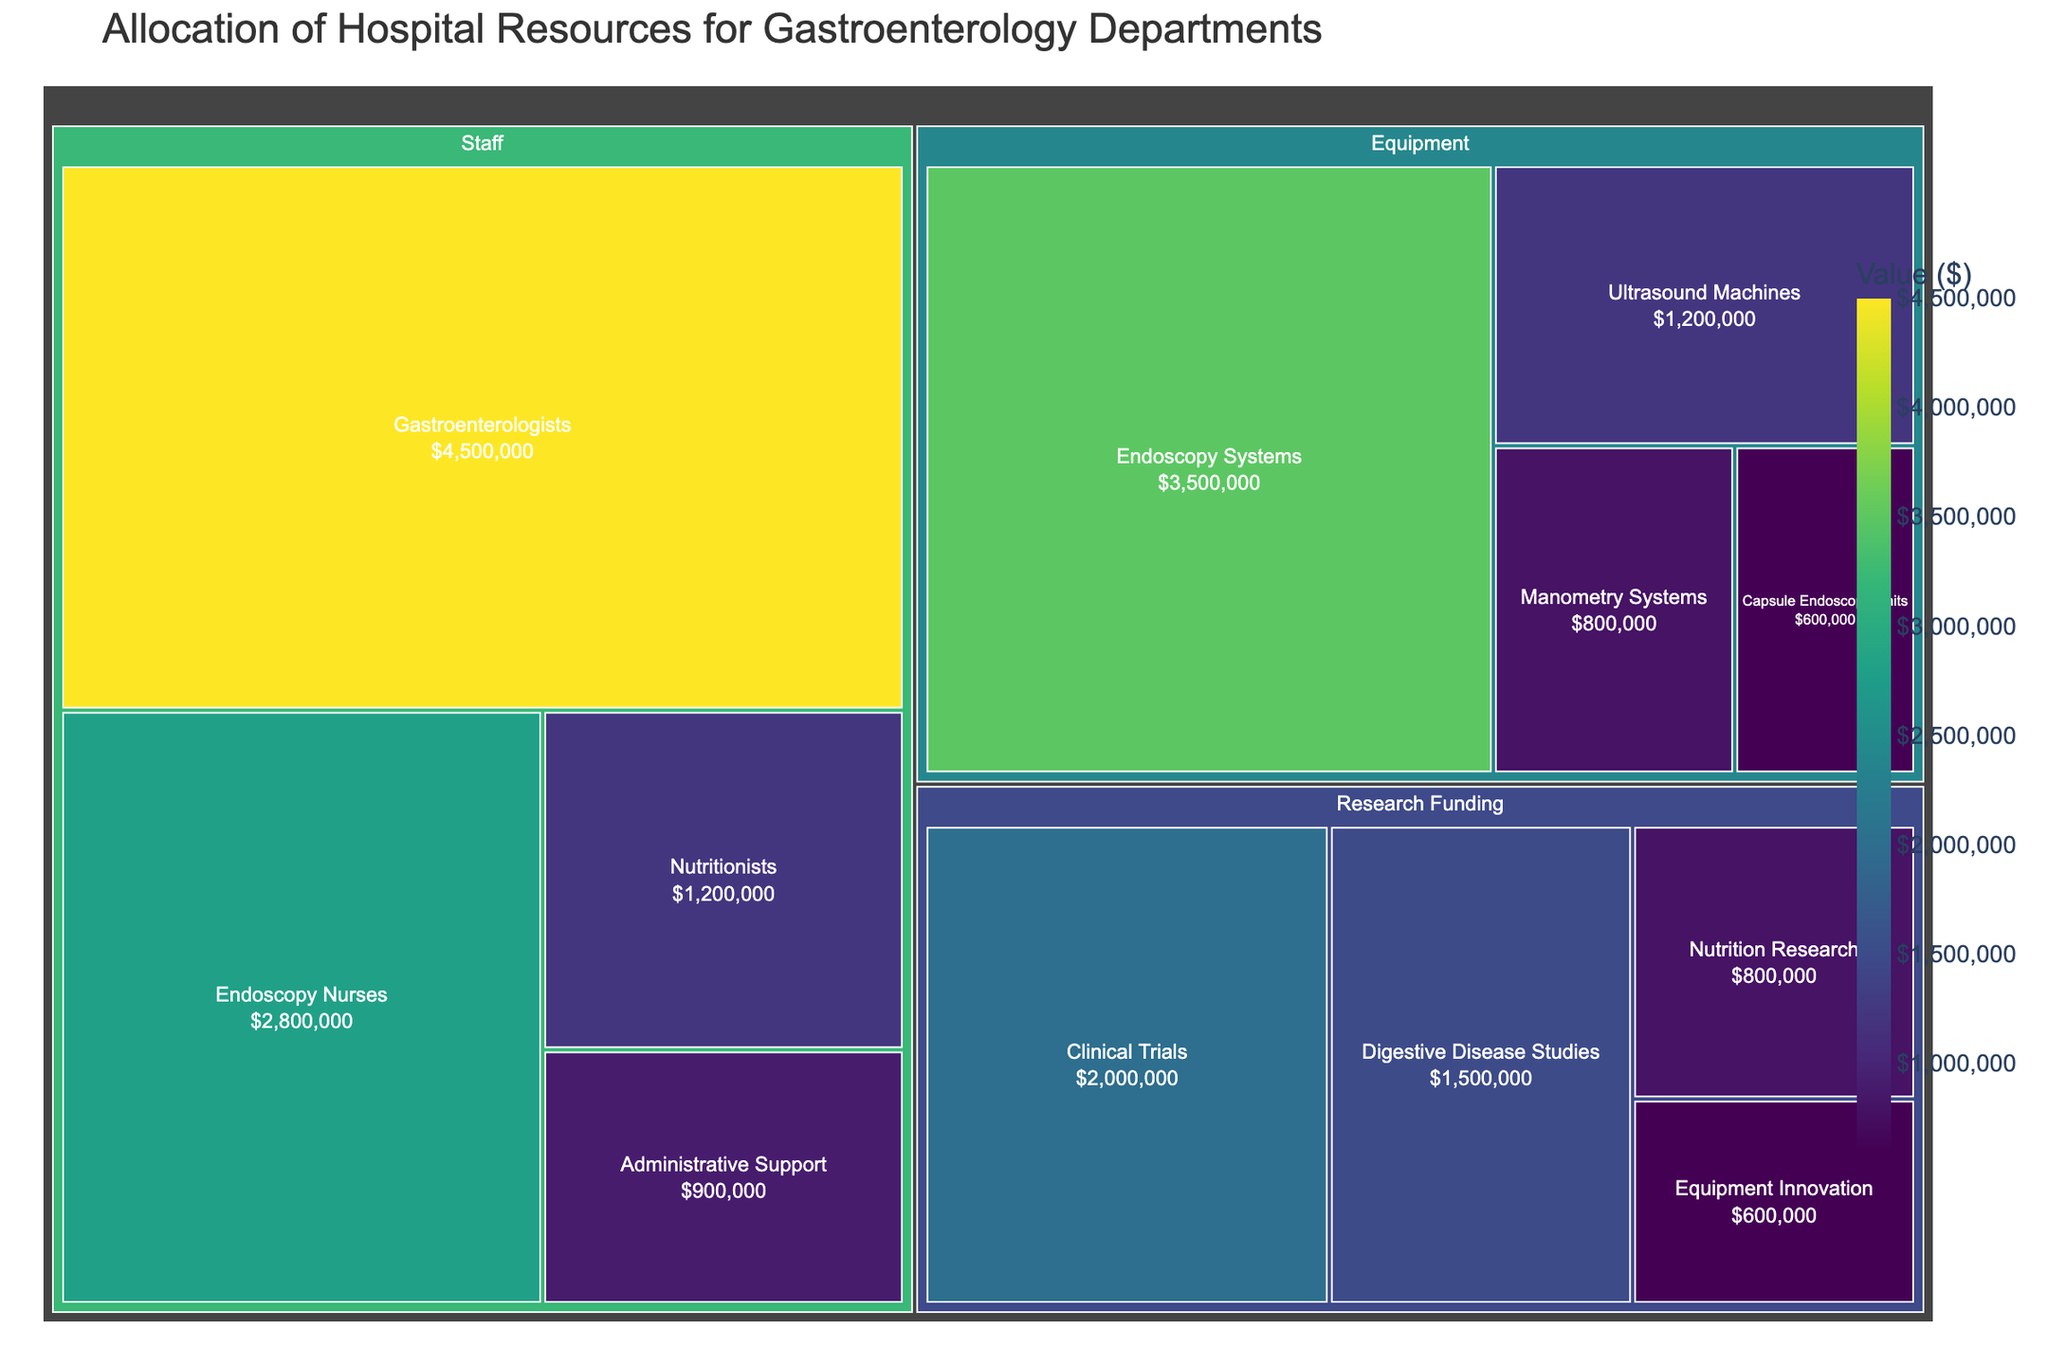What category has the highest overall allocation? By looking at the treemap, the largest portion is dedicated to 'Staff'. Hovering over its subcategories shows significant sums, especially for 'Gastroenterologists'.
Answer: Staff Which subcategory within the 'Equipment' category has the highest value? In the 'Equipment' section of the treemap, the 'Endoscopy Systems' subcategory is the largest portion visually and confirmed by the hover text.
Answer: Endoscopy Systems What is the combined value of 'Endoscopy Nurses' and 'Nutritionists' in the staff category? The value for 'Endoscopy Nurses' is $2,800,000 and for 'Nutritionists' is $1,200,000. Their combined total is 2,800,000 + 1,200,000 = $4,000,000.
Answer: $4,000,000 Which category has the least amount of funding, and what is its total value? Observing the smallest sections in the treemap shows 'Research Funding' as the smallest category. Summing up its subcategories: $2,000,000 + $1,500,000 + $800,000 + $600,000 = $4,900,000.
Answer: Research Funding, $4,900,000 What is the value allocated to 'Digestive Disease Studies'? Hovering over the 'Digestive Disease Studies' section in 'Research Funding' displays its value directly.
Answer: $1,500,000 How does the funding for 'Clinical Trials' compare to 'Digestive Disease Studies'? The value for 'Clinical Trials' is $2,000,000, while for 'Digestive Disease Studies' it is $1,500,000. Clinical Trials receive more funding by $500,000.
Answer: Clinical Trials, $500,000 more What proportion of the total 'Equipment' budget is spent on 'Ultrasound Machines'? Summing the 'Equipment' subcategories total: $3,500,000 + $1,200,000 + $800,000 + $600,000 = $6,100,000. 'Ultrasound Machines' is $1,200,000, so the proportion is 1,200,000/6,100,000 ≈ 0.197 = 19.7%.
Answer: 19.7% What is the smallest value subcategory in the entire treemap? The smallest subcategory is visually the least space occupying. Hovering shows 'Equipment Innovation' in 'Research Funding' has the smallest value of $600,000.
Answer: Equipment Innovation, $600,000 What is the total value allocated to all 'Equipment' subcategories? How does this compare to the total 'Research Funding'? Sum all subcategories of equipment: $3,500,000 + $1,200,000 + $800,000 + $600,000 = $6,100,000. Total research funding is $4,900,000. Equipment has $1,200,000 more than Research Funding.
Answer: Equipment: $6,100,000, Research Funding: $4,900,000, $1,200,000 more 